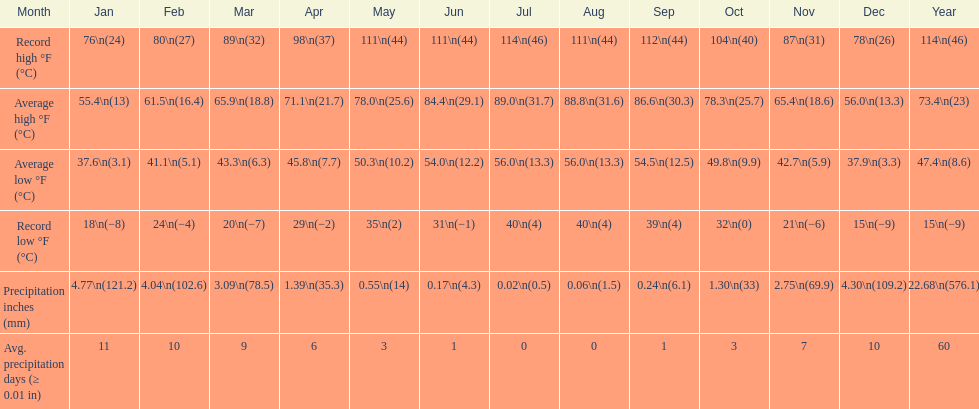In what month did the mean high reach 8 July. 